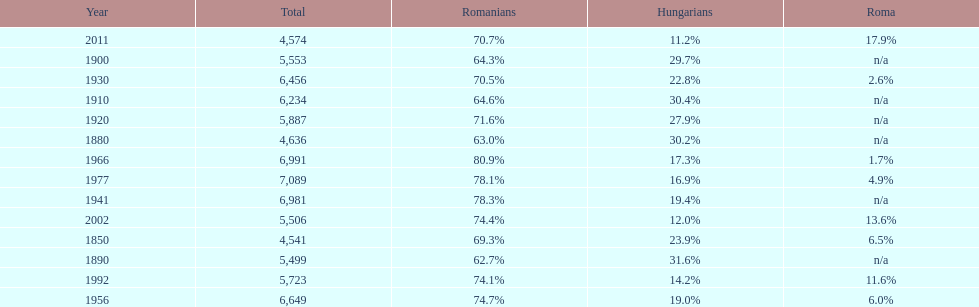Which year had a total of 6,981 and 19.4% hungarians? 1941. 